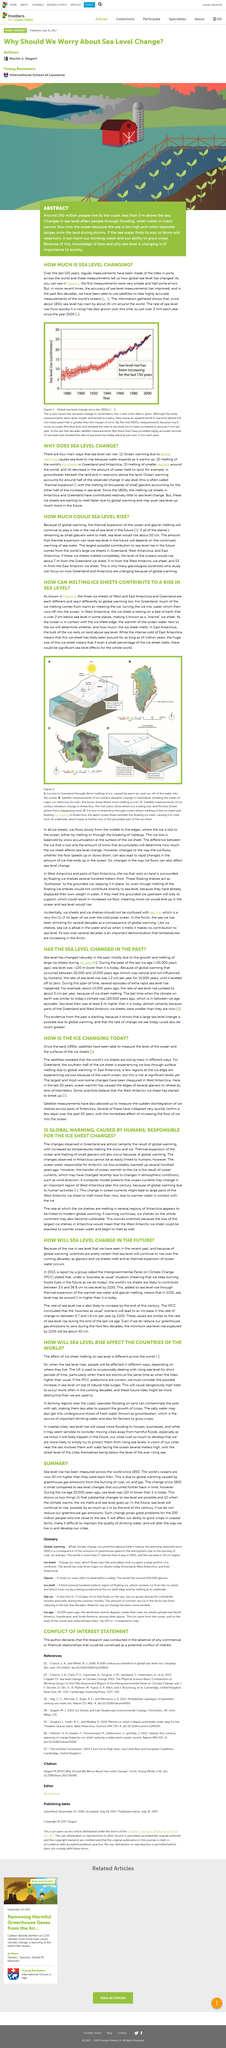Point out several critical features in this image. The article provides four (4) reasons in support of the title's question. If sea water enters farms and reservoirs, it can compromise the quality of our drinking water and hinder our ability to grow crops. The article is discussing the ice regions of Greenland, East Antarctica, and West Antarctica. Melting ice sheets can be found in places other than Greenland, such as Antarctica. Ocean warming leads to thermal expansion, resulting in a rise in sea level, which is commonly referred to as the change in sea level due to thermal expansion. 